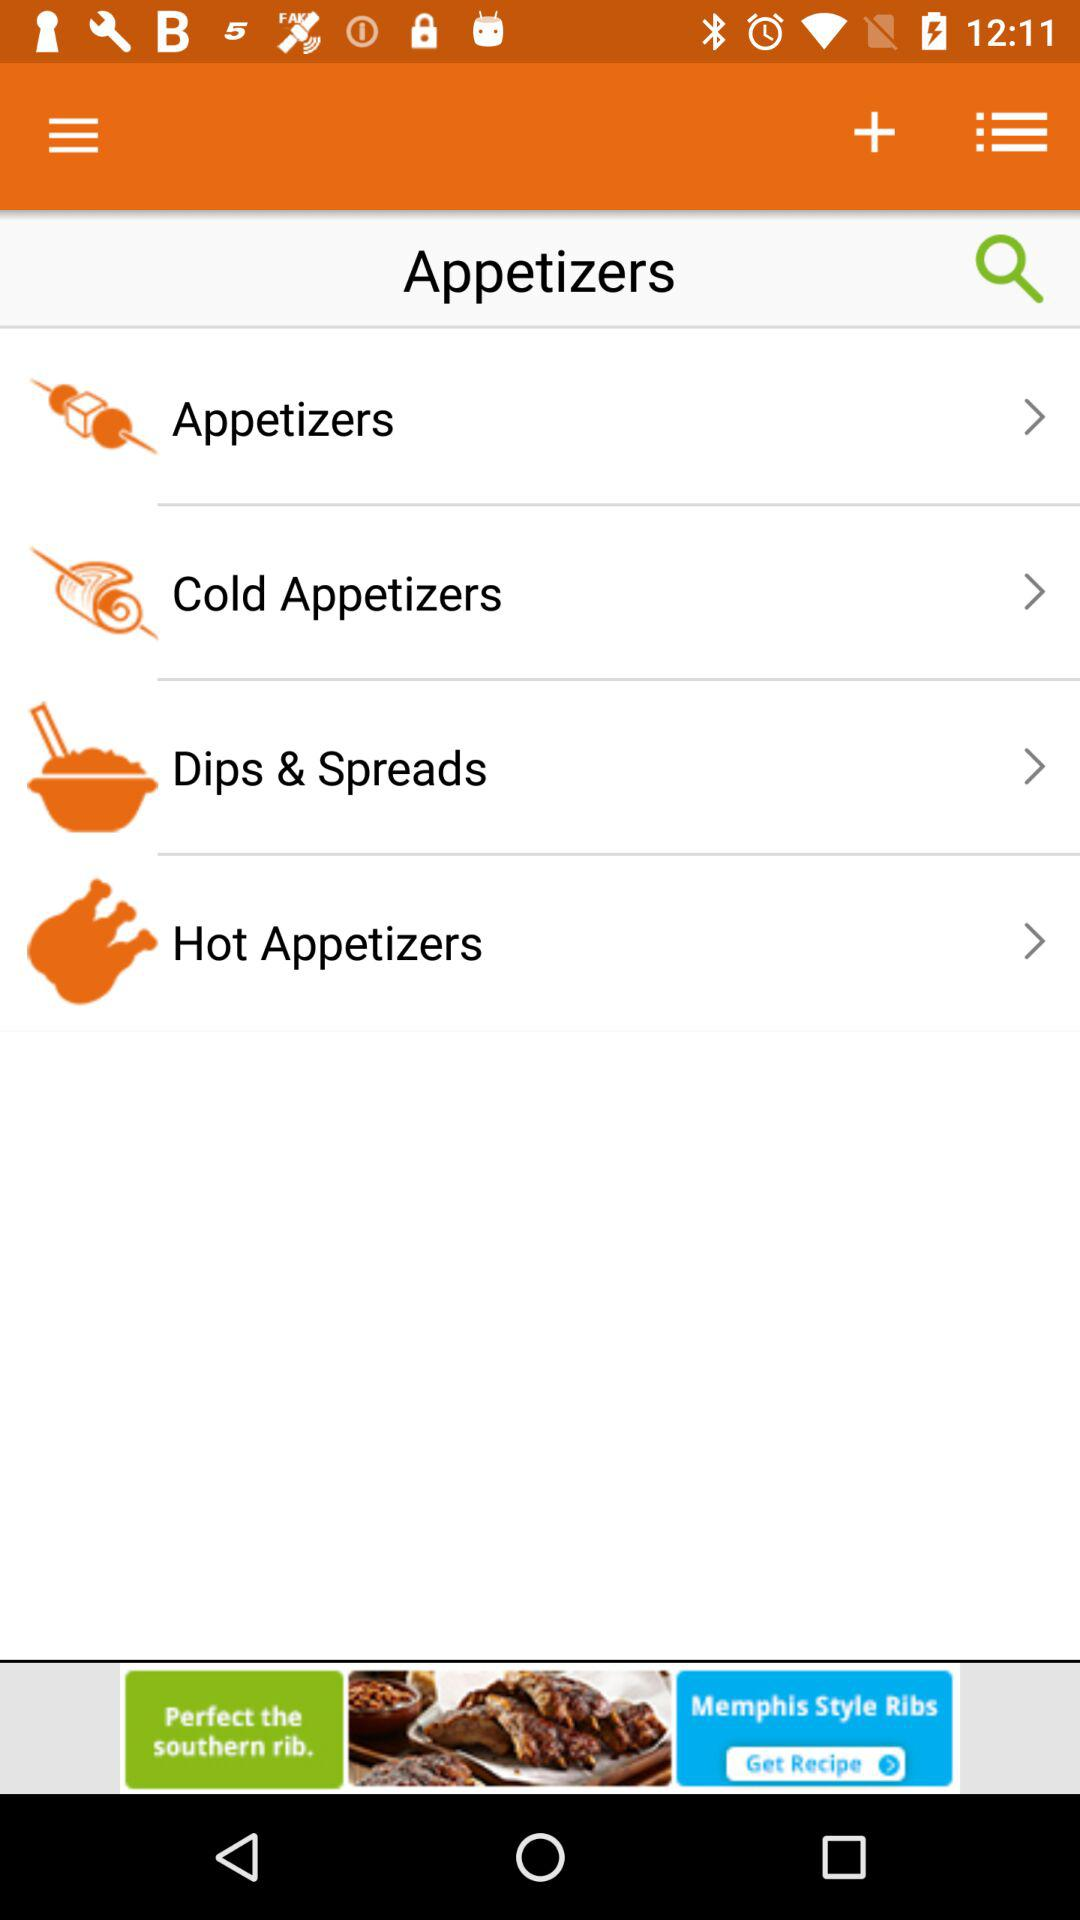What dish is searched for? The searched dish is "Appetizers". 